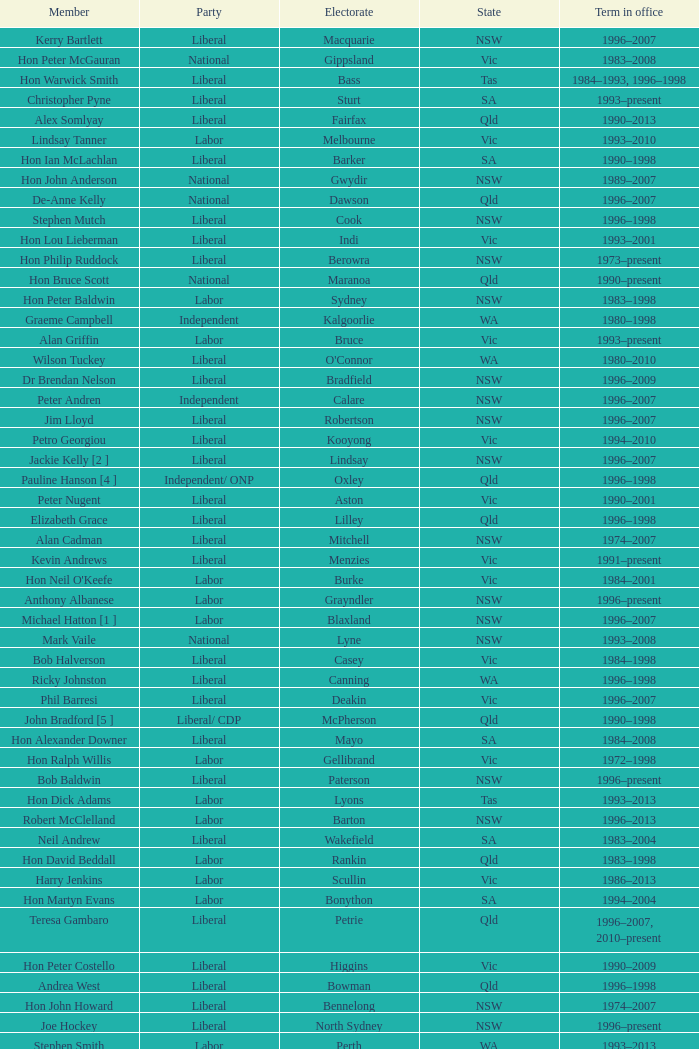In what state was the electorate fowler? NSW. Parse the table in full. {'header': ['Member', 'Party', 'Electorate', 'State', 'Term in office'], 'rows': [['Kerry Bartlett', 'Liberal', 'Macquarie', 'NSW', '1996–2007'], ['Hon Peter McGauran', 'National', 'Gippsland', 'Vic', '1983–2008'], ['Hon Warwick Smith', 'Liberal', 'Bass', 'Tas', '1984–1993, 1996–1998'], ['Christopher Pyne', 'Liberal', 'Sturt', 'SA', '1993–present'], ['Alex Somlyay', 'Liberal', 'Fairfax', 'Qld', '1990–2013'], ['Lindsay Tanner', 'Labor', 'Melbourne', 'Vic', '1993–2010'], ['Hon Ian McLachlan', 'Liberal', 'Barker', 'SA', '1990–1998'], ['Hon John Anderson', 'National', 'Gwydir', 'NSW', '1989–2007'], ['De-Anne Kelly', 'National', 'Dawson', 'Qld', '1996–2007'], ['Stephen Mutch', 'Liberal', 'Cook', 'NSW', '1996–1998'], ['Hon Lou Lieberman', 'Liberal', 'Indi', 'Vic', '1993–2001'], ['Hon Philip Ruddock', 'Liberal', 'Berowra', 'NSW', '1973–present'], ['Hon Bruce Scott', 'National', 'Maranoa', 'Qld', '1990–present'], ['Hon Peter Baldwin', 'Labor', 'Sydney', 'NSW', '1983–1998'], ['Graeme Campbell', 'Independent', 'Kalgoorlie', 'WA', '1980–1998'], ['Alan Griffin', 'Labor', 'Bruce', 'Vic', '1993–present'], ['Wilson Tuckey', 'Liberal', "O'Connor", 'WA', '1980–2010'], ['Dr Brendan Nelson', 'Liberal', 'Bradfield', 'NSW', '1996–2009'], ['Peter Andren', 'Independent', 'Calare', 'NSW', '1996–2007'], ['Jim Lloyd', 'Liberal', 'Robertson', 'NSW', '1996–2007'], ['Petro Georgiou', 'Liberal', 'Kooyong', 'Vic', '1994–2010'], ['Jackie Kelly [2 ]', 'Liberal', 'Lindsay', 'NSW', '1996–2007'], ['Pauline Hanson [4 ]', 'Independent/ ONP', 'Oxley', 'Qld', '1996–1998'], ['Peter Nugent', 'Liberal', 'Aston', 'Vic', '1990–2001'], ['Elizabeth Grace', 'Liberal', 'Lilley', 'Qld', '1996–1998'], ['Alan Cadman', 'Liberal', 'Mitchell', 'NSW', '1974–2007'], ['Kevin Andrews', 'Liberal', 'Menzies', 'Vic', '1991–present'], ["Hon Neil O'Keefe", 'Labor', 'Burke', 'Vic', '1984–2001'], ['Anthony Albanese', 'Labor', 'Grayndler', 'NSW', '1996–present'], ['Michael Hatton [1 ]', 'Labor', 'Blaxland', 'NSW', '1996–2007'], ['Mark Vaile', 'National', 'Lyne', 'NSW', '1993–2008'], ['Bob Halverson', 'Liberal', 'Casey', 'Vic', '1984–1998'], ['Ricky Johnston', 'Liberal', 'Canning', 'WA', '1996–1998'], ['Phil Barresi', 'Liberal', 'Deakin', 'Vic', '1996–2007'], ['John Bradford [5 ]', 'Liberal/ CDP', 'McPherson', 'Qld', '1990–1998'], ['Hon Alexander Downer', 'Liberal', 'Mayo', 'SA', '1984–2008'], ['Hon Ralph Willis', 'Labor', 'Gellibrand', 'Vic', '1972–1998'], ['Bob Baldwin', 'Liberal', 'Paterson', 'NSW', '1996–present'], ['Hon Dick Adams', 'Labor', 'Lyons', 'Tas', '1993–2013'], ['Robert McClelland', 'Labor', 'Barton', 'NSW', '1996–2013'], ['Neil Andrew', 'Liberal', 'Wakefield', 'SA', '1983–2004'], ['Hon David Beddall', 'Labor', 'Rankin', 'Qld', '1983–1998'], ['Harry Jenkins', 'Labor', 'Scullin', 'Vic', '1986–2013'], ['Hon Martyn Evans', 'Labor', 'Bonython', 'SA', '1994–2004'], ['Teresa Gambaro', 'Liberal', 'Petrie', 'Qld', '1996–2007, 2010–present'], ['Hon Peter Costello', 'Liberal', 'Higgins', 'Vic', '1990–2009'], ['Andrea West', 'Liberal', 'Bowman', 'Qld', '1996–1998'], ['Hon John Howard', 'Liberal', 'Bennelong', 'NSW', '1974–2007'], ['Joe Hockey', 'Liberal', 'North Sydney', 'NSW', '1996–present'], ['Stephen Smith', 'Labor', 'Perth', 'WA', '1993–2013'], ['Mal Brough', 'Liberal', 'Longman', 'Qld', '1996–2007'], ['Hon Kim Beazley', 'Labor', 'Brand', 'WA', '1980–2007'], ['Hon Bob McMullan', 'Labor', 'Canberra', 'ACT', '1996–2010'], ['Martin Ferguson', 'Labor', 'Batman', 'Vic', '1996–2013'], ['Hon Ian Sinclair', 'National', 'New England', 'NSW', '1963–1998'], ['Danna Vale', 'Liberal', 'Hughes', 'NSW', '1996–2010'], ['Hon Bruce Reid', 'Liberal', 'Bendigo', 'Vic', '1990–1998'], ['Hon Peter Morris', 'Labor', 'Shortland', 'NSW', '1972–1998'], ['Ted Grace', 'Labor', 'Fowler', 'NSW', '1984–1998'], ['Hon Ian Causley', 'National', 'Page', 'NSW', '1996–2007'], ['John Fahey', 'Liberal', 'Macarthur', 'NSW', '1996–2001'], ['Michael Cobb', 'National', 'Parkes', 'NSW', '1984–1998'], ['Warren Entsch', 'Liberal', 'Leichhardt', 'Qld', '1996–2007, 2010–present'], ['Hon Tony Abbott', 'Liberal', 'Warringah', 'NSW', '1994–present'], ['Frank Mossfield', 'Labor', 'Greenway', 'NSW', '1996–2004'], ['Annette Ellis', 'Labor', 'Namadgi', 'ACT', '1996–2010'], ['Tony Smith', 'Liberal/Independent [7 ]', 'Dickson', 'Qld', '1996–1998'], ['Russell Broadbent', 'Liberal', 'McMillan', 'Vic', '1990–1993, 1996–1998 2004–present'], ['Hon Michael Wooldridge', 'Liberal', 'Casey', 'Vic', '1987–2001'], ['Bob Sercombe', 'Labor', 'Maribyrnong', 'Vic', '1996–2007'], ['Hon Tim Fischer', 'National', 'Farrer', 'NSW', '1984–2001'], ['Bob Charles', 'Liberal', 'La Trobe', 'Vic', '1990–2004'], ['Hon Chris Miles', 'Liberal', 'Braddon', 'Tas', '1984–1998'], ['Paul Marek', 'National', 'Capricornia', 'Qld', '1996–1998'], ['David Hawker', 'Liberal', 'Wannon', 'Vic', '1983–2010'], ['Peter Lindsay', 'Liberal', 'Herbert', 'Qld', '1996–2010'], ['Hon Gareth Evans', 'Labor', 'Holt', 'Vic', '1996–1999'], ['Stewart McArthur', 'Liberal', 'Corangamite', 'Vic', '1984–2007'], ['Hon Janice Crosio', 'Labor', 'Prospect', 'NSW', '1990–2004'], ['Hon David Jull', 'Liberal', 'Fadden', 'Qld', '1975–1983, 1984–2007'], ['Christine Gallus', 'Liberal', 'Hindmarsh', 'SA', '1990–2004'], ['Hon Barry Jones', 'Labor', 'Lalor', 'Vic', '1977–1998'], ['Kay Elson', 'Liberal', 'Forde', 'Qld', '1996–2007'], ['Allan Morris', 'Labor', 'Newcastle', 'NSW', '1983–2001'], ['Hon Andrew Thomson', 'Liberal', 'Wentworth', 'NSW', '1995–2001'], ['Paul Neville', 'National', 'Hinkler', 'Qld', '1993–2013'], ['Hon Geoff Prosser', 'Liberal', 'Forrest', 'WA', '1987–2007'], ['Hon Bob Katter', 'National', 'Kennedy', 'Qld', '1993–present'], ['Paul Keating [1 ]', 'Labor', 'Blaxland', 'NSW', '1969–1996'], ['Dr Sharman Stone', 'Liberal', 'Murray', 'Vic', '1996–present'], ['Fran Bailey', 'Liberal', 'McEwen', 'Vic', '1990–1993, 1996–2010'], ['Hon Judi Moylan', 'Liberal', 'Pearce', 'WA', '1993–2013'], ['John Langmore [3 ]', 'Labor', 'Fraser', 'ACT', '1984–1997'], ["Gavan O'Connor", 'Labor', 'Corio', 'Vic', '1993–2007'], ['Greg Wilton', 'Labor', 'Isaacs', 'Vic', '1996–2000'], ['Ross Cameron', 'Liberal', 'Parramatta', 'NSW', '1996–2004'], ['Nick Dondas', 'CLP', 'Northern Territory', 'NT', '1996–1998'], ['Gary Nairn', 'Liberal', 'Eden-Monaro', 'NSW', '1996–2007'], ['Joanna Gash', 'Liberal', 'Gilmore', 'NSW', '1996–2013'], ['Allan Rocher', 'Independent', 'Curtin', 'WA', '1981–1998'], ['Trish Worth', 'Liberal', 'Adelaide', 'SA', '1996–2004'], ['John Forrest', 'National', 'Mallee', 'Vic', '1993–2013'], ['Graeme McDougall', 'Liberal', 'Griffith', 'Qld', '1996–1998'], ['Don Randall', 'Liberal', 'Swan', 'WA', '1996–1998, 2001–present'], ['Dr Andrew Southcott', 'Liberal', 'Boothby', 'SA', '1996–present'], ['Hon Clyde Holding', 'Labor', 'Melbourne Ports', 'Vic', '1977–1998'], ['Gary Hardgrave', 'Liberal', 'Moreton', 'Qld', '1996–2007'], ['Richard Evans', 'Liberal', 'Cowan', 'WA', '1993–1998'], ['Garry Nehl', 'National', 'Cowper', 'NSW', '1984–2001'], ['Bruce Billson', 'Liberal', 'Dunkley', 'Vic', '1996–present'], ['Warren Truss', 'National', 'Wide Bay', 'Qld', '1990–present'], ['Hon Arch Bevis', 'Labor', 'Brisbane', 'Qld', '1990–2010'], ['Hon John Moore', 'Liberal', 'Ryan', 'Qld', '1975–2001'], ['Bill Taylor', 'Liberal', 'Groom', 'Qld', '1988–1998'], ['Paul Zammit', 'Liberal/Independent [6 ]', 'Lowe', 'NSW', '1996–1998'], ['Hon Stephen Martin', 'Labor', 'Cunningham', 'NSW', '1984–2002'], ['Daryl Melham', 'Labor', 'Banks', 'NSW', '1990–2013'], ['Trish Draper', 'Liberal', 'Makin', 'SA', '1996–2007'], ['Hon Dr David Kemp', 'Liberal', 'Goldstein', 'Vic', '1990–2004'], ['Steve Dargavel [3 ]', 'Labor', 'Fraser', 'ACT', '1997–1998'], ['Hon Simon Crean', 'Labor', 'Hotham', 'Vic', '1990–2013'], ['Hon Andrew Theophanous', 'Labor', 'Calwell', 'Vic', '1980–2001'], ['Hon Michael Lee', 'Labor', 'Dobell', 'NSW', '1984–2001'], ['Susan Jeanes', 'Liberal', 'Kingston', 'SA', '1996–1998'], ['Rod Sawford', 'Labor', 'Adelaide', 'SA', '1988–2007'], ['Kelvin Thomson', 'Labor', 'Wills', 'Vic', '1996–present'], ['Hon Bob Brown', 'Labor', 'Charlton', 'NSW', '1980–1998'], ['Jenny Macklin', 'Labor', 'Jagajaga', 'Vic', '1996–present'], ['Larry Anthony', 'National', 'Richmond', 'NSW', '1996–2004'], ['Peter Slipper', 'Liberal', 'Fisher', 'Qld', '1984–1987, 1993–2013'], ['Hon Bronwyn Bishop', 'Liberal', 'Mackellar', 'NSW', '1994–present'], ['Hon Duncan Kerr', 'Labor', 'Denison', 'Tas', '1987–2010'], ['Noel Hicks', 'National', 'Riverina', 'NSW', '1980–1998'], ['Hon Peter Reith', 'Liberal', 'Flinders', 'Vic', '1982–1983, 1984–2001'], ['Hon Daryl Williams', 'Liberal', 'Tangney', 'WA', '1993–2004'], ['Kathy Sullivan', 'Liberal', 'Moncrieff', 'Qld', '1984–2001'], ['Hon Dr Carmen Lawrence', 'Labor', 'Fremantle', 'WA', '1994–2007'], ['Hon Leo McLeay', 'Labor', 'Watson', 'NSW', '1979–2004'], ['Laurie Ferguson', 'Labor', 'Reid', 'NSW', '1990–present'], ['Hon John Sharp', 'National', 'Hume', 'NSW', '1984–1998'], ['Hon Laurie Brereton', 'Labor', 'Kingsford Smith', 'NSW', '1990–2004'], ['Colin Hollis', 'Labor', 'Throsby', 'NSW', '1984–2001'], ['Hon Roger Price', 'Labor', 'Chifley', 'NSW', '1984–2010'], ['Barry Wakelin', 'Liberal', 'Grey', 'SA', '1993–2007'], ['Eoin Cameron', 'Liberal', 'Stirling', 'WA', '1993–1998'], ['Mark Latham', 'Labor', 'Werriwa', 'NSW', '1994–2005'], ['Michael Ronaldson', 'Liberal', 'Ballarat', 'Vic', '1990–2001'], ['Joel Fitzgibbon', 'Labor', 'Hunter', 'NSW', '1996–present'], ['Paul Filing', 'Independent', 'Moore', 'WA', '1990–1998'], ['Harry Quick', 'Labor', 'Franklin', 'Tas', '1993–2007']]} 